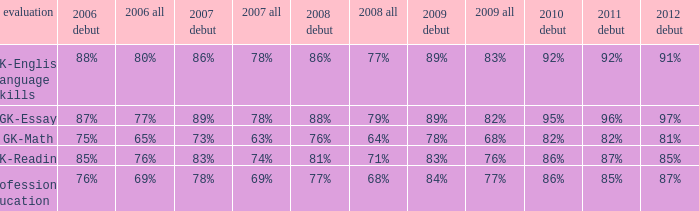What is the percentage for all in 2007 when all in 2006 was 65%? 63%. 